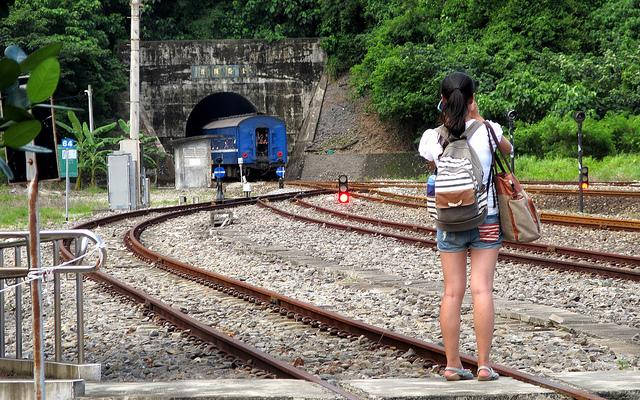What is the girl wearing? shorts 